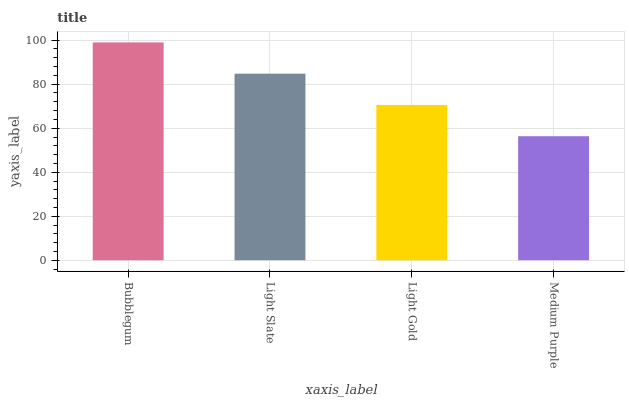Is Medium Purple the minimum?
Answer yes or no. Yes. Is Bubblegum the maximum?
Answer yes or no. Yes. Is Light Slate the minimum?
Answer yes or no. No. Is Light Slate the maximum?
Answer yes or no. No. Is Bubblegum greater than Light Slate?
Answer yes or no. Yes. Is Light Slate less than Bubblegum?
Answer yes or no. Yes. Is Light Slate greater than Bubblegum?
Answer yes or no. No. Is Bubblegum less than Light Slate?
Answer yes or no. No. Is Light Slate the high median?
Answer yes or no. Yes. Is Light Gold the low median?
Answer yes or no. Yes. Is Light Gold the high median?
Answer yes or no. No. Is Bubblegum the low median?
Answer yes or no. No. 